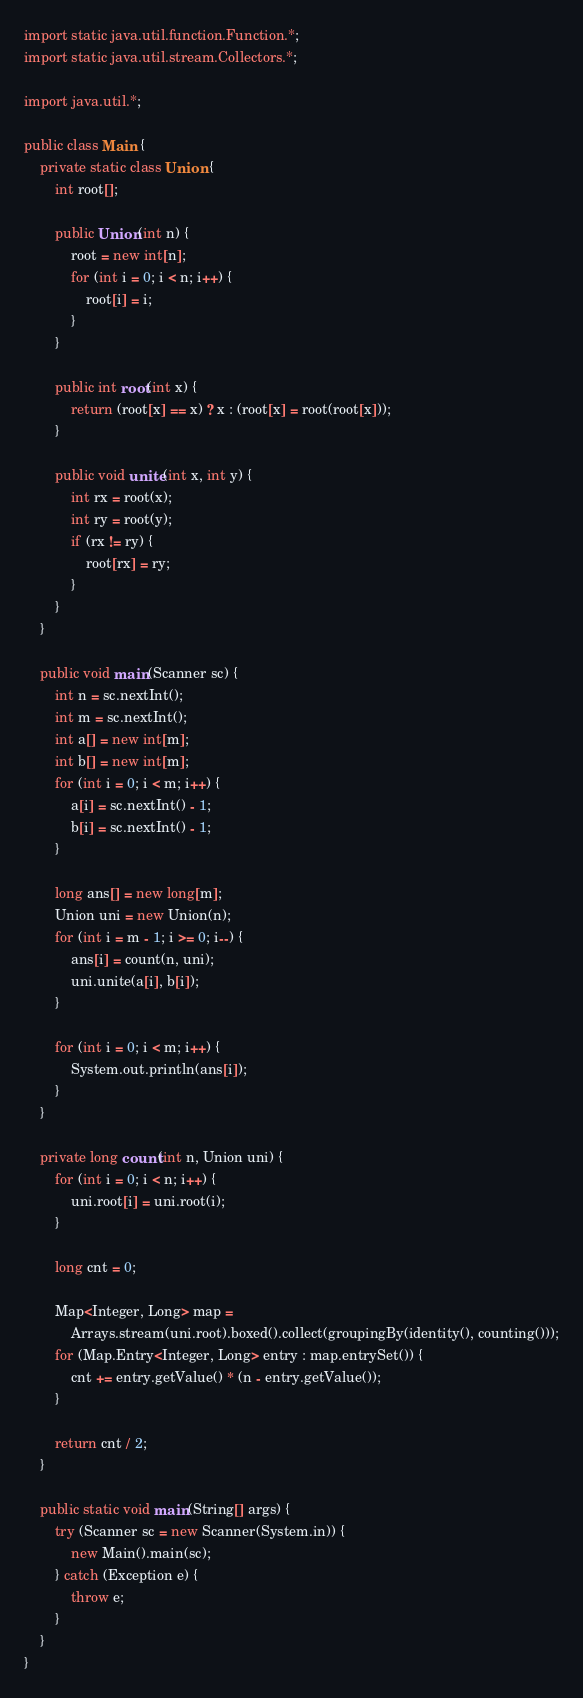<code> <loc_0><loc_0><loc_500><loc_500><_Java_>import static java.util.function.Function.*;
import static java.util.stream.Collectors.*;

import java.util.*;

public class Main {
    private static class Union {
        int root[];

        public Union(int n) {
            root = new int[n];
            for (int i = 0; i < n; i++) {
                root[i] = i;
            }
        }

        public int root(int x) {
            return (root[x] == x) ? x : (root[x] = root(root[x]));
        }

        public void unite(int x, int y) {
            int rx = root(x);
            int ry = root(y);
            if (rx != ry) {
                root[rx] = ry;
            }
        }
    }

    public void main(Scanner sc) {
        int n = sc.nextInt();
        int m = sc.nextInt();
        int a[] = new int[m];
        int b[] = new int[m];
        for (int i = 0; i < m; i++) {
            a[i] = sc.nextInt() - 1;
            b[i] = sc.nextInt() - 1;
        }

        long ans[] = new long[m];
        Union uni = new Union(n);
        for (int i = m - 1; i >= 0; i--) {
            ans[i] = count(n, uni);
            uni.unite(a[i], b[i]);
        }

        for (int i = 0; i < m; i++) {
            System.out.println(ans[i]);
        }
    }

    private long count(int n, Union uni) {
        for (int i = 0; i < n; i++) {
            uni.root[i] = uni.root(i);
        }

        long cnt = 0;

        Map<Integer, Long> map =
            Arrays.stream(uni.root).boxed().collect(groupingBy(identity(), counting()));
        for (Map.Entry<Integer, Long> entry : map.entrySet()) {
            cnt += entry.getValue() * (n - entry.getValue());
        }

        return cnt / 2;
    }

    public static void main(String[] args) {
        try (Scanner sc = new Scanner(System.in)) {
            new Main().main(sc);
        } catch (Exception e) {
            throw e;
        }
    }
}
</code> 